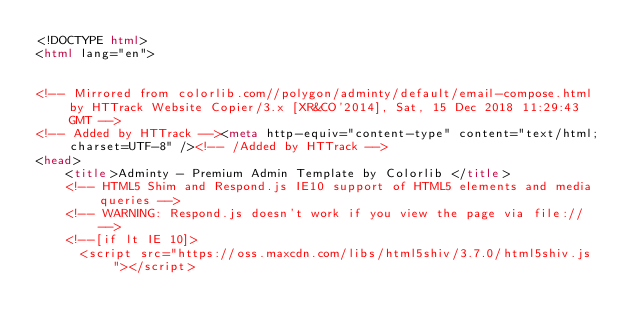Convert code to text. <code><loc_0><loc_0><loc_500><loc_500><_HTML_><!DOCTYPE html>
<html lang="en">


<!-- Mirrored from colorlib.com//polygon/adminty/default/email-compose.html by HTTrack Website Copier/3.x [XR&CO'2014], Sat, 15 Dec 2018 11:29:43 GMT -->
<!-- Added by HTTrack --><meta http-equiv="content-type" content="text/html;charset=UTF-8" /><!-- /Added by HTTrack -->
<head>
    <title>Adminty - Premium Admin Template by Colorlib </title>
    <!-- HTML5 Shim and Respond.js IE10 support of HTML5 elements and media queries -->
    <!-- WARNING: Respond.js doesn't work if you view the page via file:// -->
    <!--[if lt IE 10]>
      <script src="https://oss.maxcdn.com/libs/html5shiv/3.7.0/html5shiv.js"></script></code> 